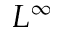Convert formula to latex. <formula><loc_0><loc_0><loc_500><loc_500>L ^ { \infty }</formula> 